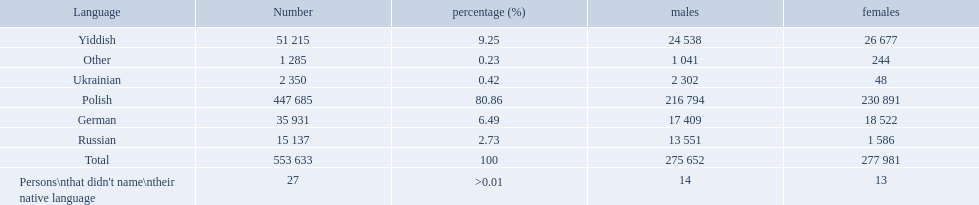What language makes a majority Polish. What the the total number of speakers? 553 633. What was the least spoken language Ukrainian. What was the most spoken? Polish. 